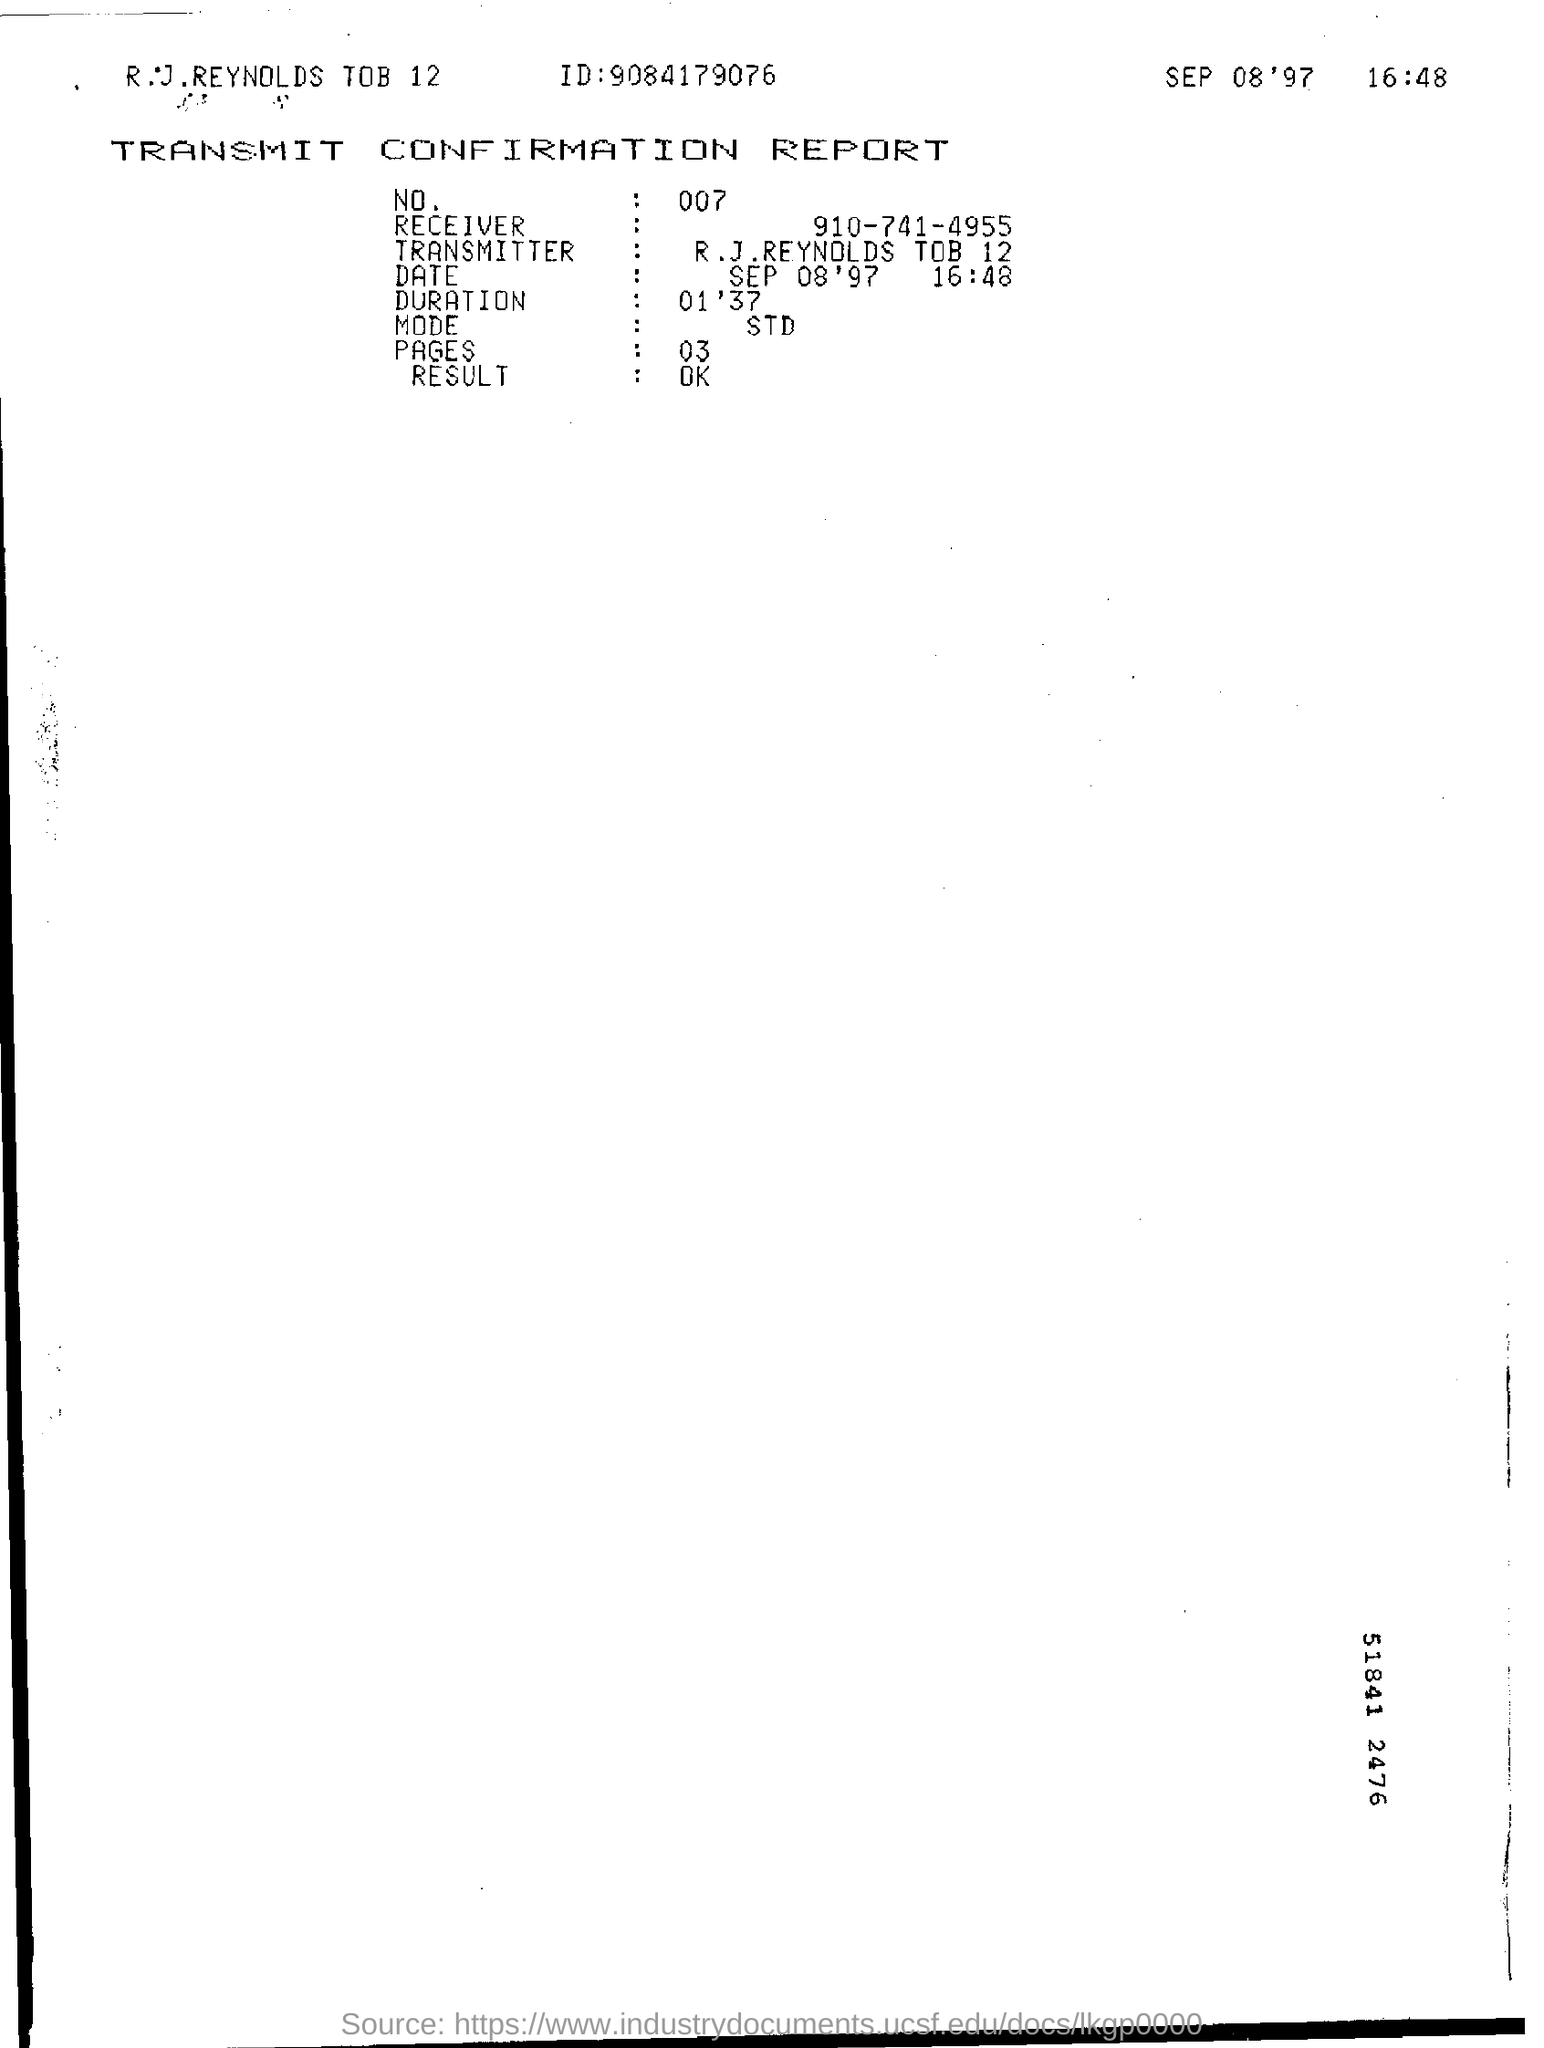Draw attention to some important aspects in this diagram. What mode is being referred to? STD. The number on the report is 007. The ID mentioned in the report is 9084179076. 